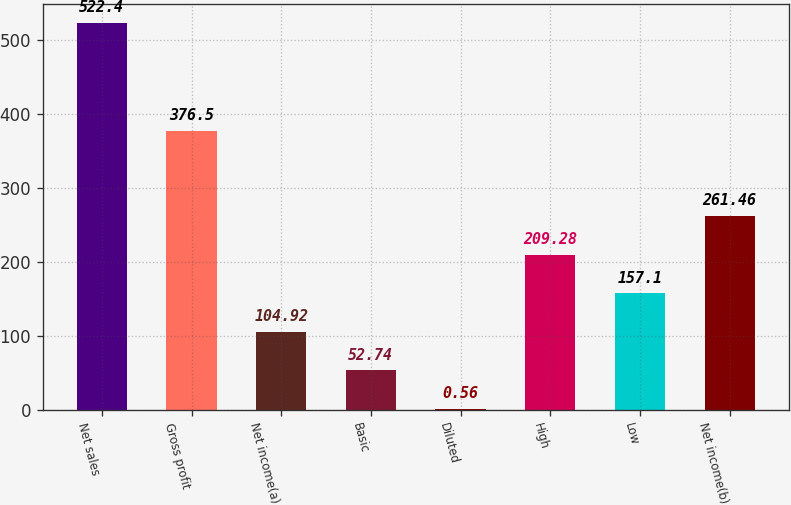Convert chart to OTSL. <chart><loc_0><loc_0><loc_500><loc_500><bar_chart><fcel>Net sales<fcel>Gross profit<fcel>Net income(a)<fcel>Basic<fcel>Diluted<fcel>High<fcel>Low<fcel>Net income(b)<nl><fcel>522.4<fcel>376.5<fcel>104.92<fcel>52.74<fcel>0.56<fcel>209.28<fcel>157.1<fcel>261.46<nl></chart> 